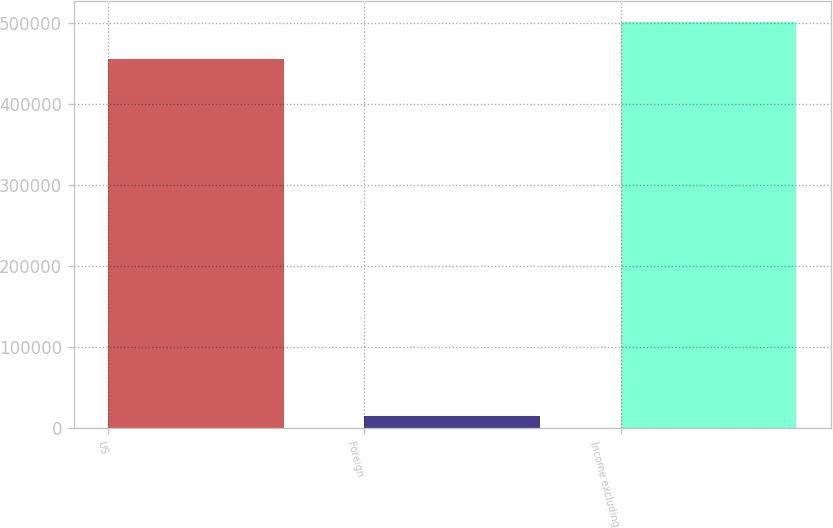Convert chart to OTSL. <chart><loc_0><loc_0><loc_500><loc_500><bar_chart><fcel>US<fcel>Foreign<fcel>Income excluding<nl><fcel>456175<fcel>15350<fcel>501792<nl></chart> 